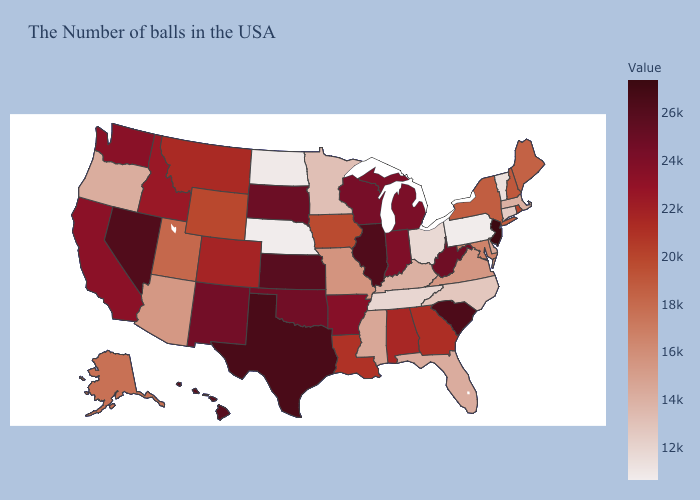Does Utah have a higher value than Ohio?
Be succinct. Yes. Does Georgia have a lower value than New York?
Be succinct. No. Among the states that border Idaho , does Washington have the lowest value?
Write a very short answer. No. Does Minnesota have a higher value than Arizona?
Give a very brief answer. No. Which states have the lowest value in the West?
Write a very short answer. Oregon. Which states have the lowest value in the USA?
Concise answer only. Nebraska. Among the states that border Arizona , does Colorado have the lowest value?
Give a very brief answer. No. Which states have the lowest value in the USA?
Keep it brief. Nebraska. Does Nebraska have the lowest value in the USA?
Concise answer only. Yes. 